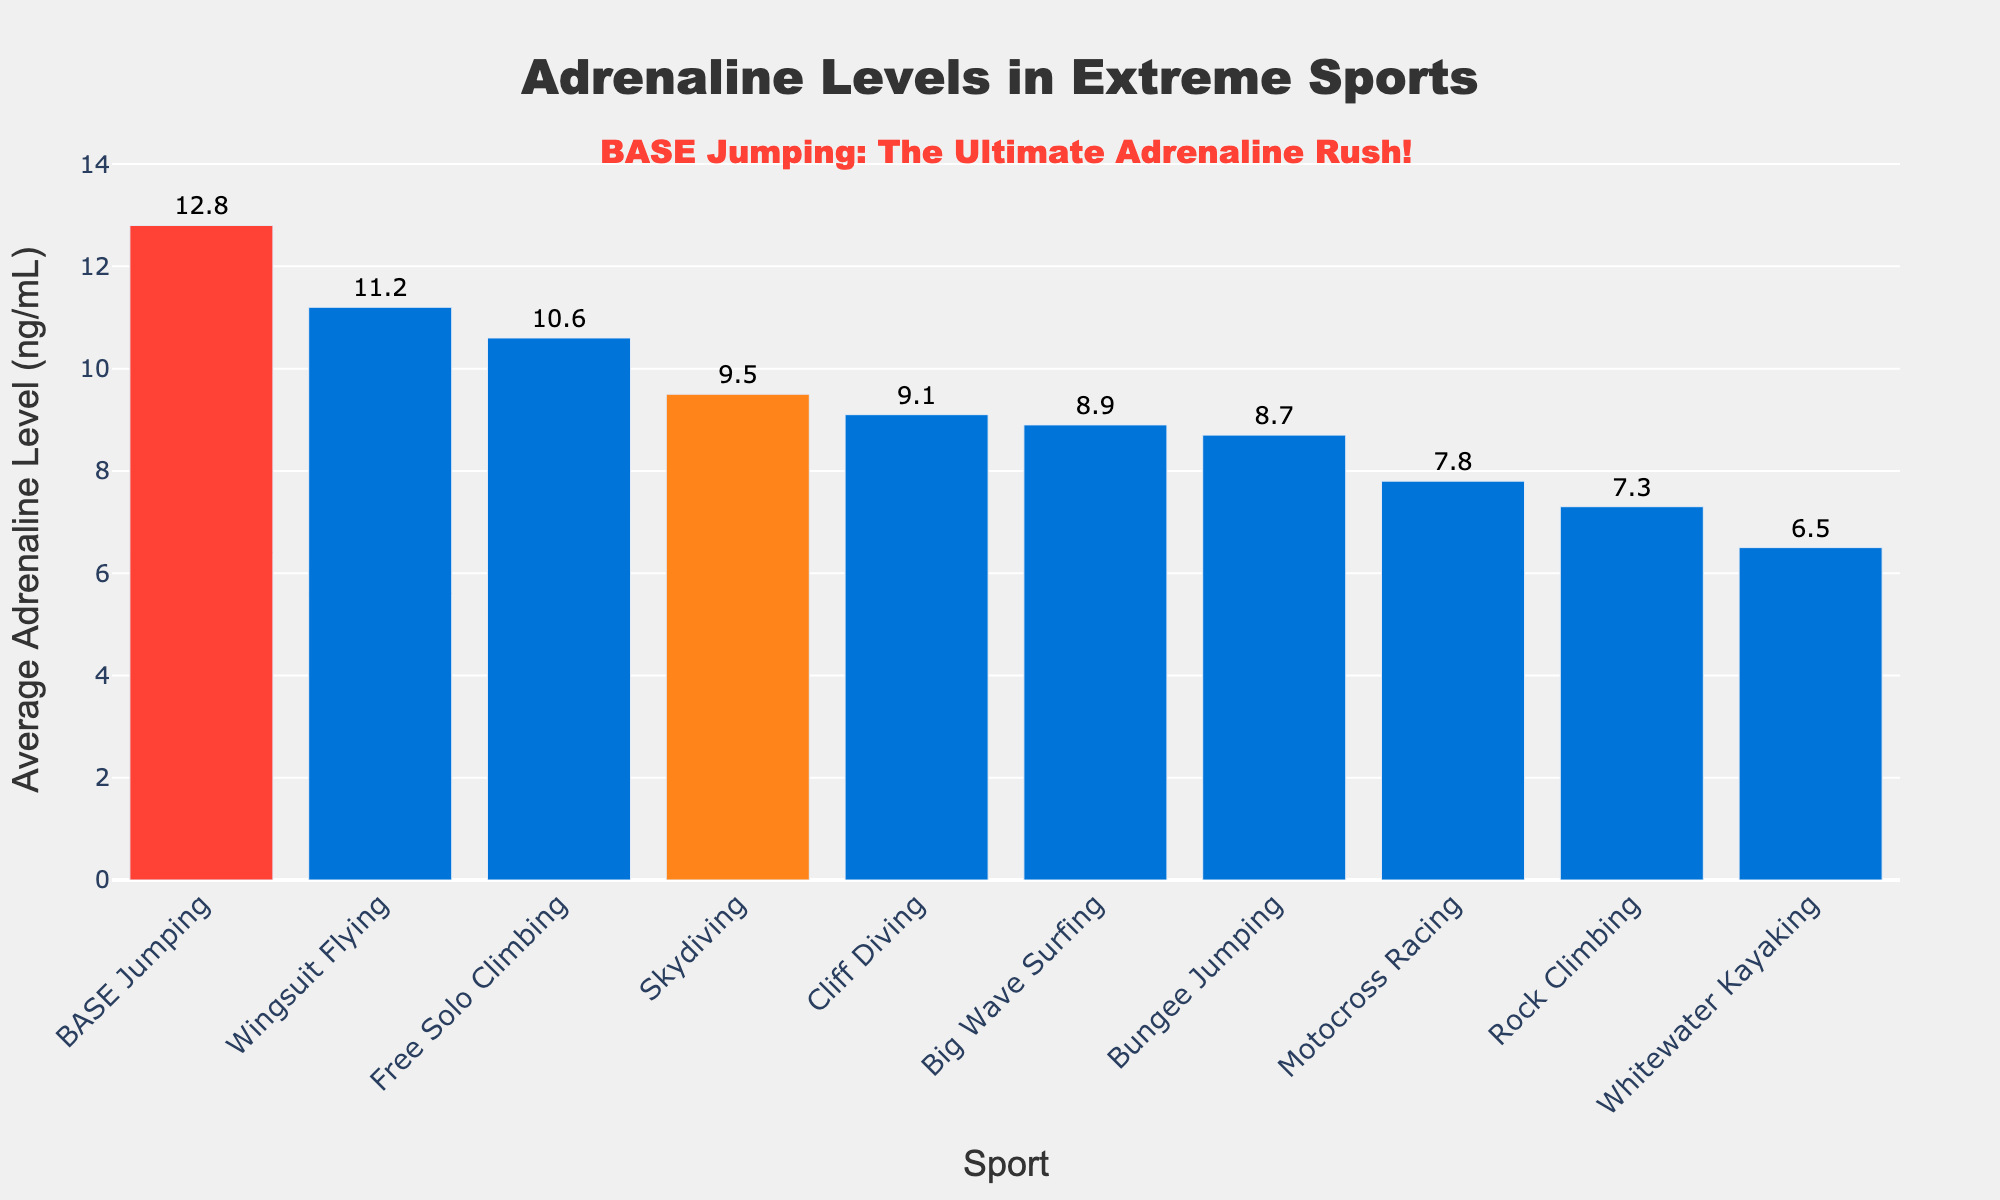What sport has the highest average adrenaline level? By looking at the figure, the highest bar corresponds to BASE Jumping. The text above the bar shows an adrenaline level of 12.8 ng/mL.
Answer: BASE Jumping Which sport has a higher adrenaline level, Bungee Jumping or Big Wave Surfing? By comparing the heights of the bars, Big Wave Surfing has a higher level (8.9 ng/mL) than Bungee Jumping (8.7 ng/mL).
Answer: Big Wave Surfing How much higher is the adrenaline level for BASE Jumping compared to Skydiving? The adrenaline level for BASE Jumping is 12.8 ng/mL, and for Skydiving, it is 9.5 ng/mL. Subtraction gives 12.8 - 9.5 = 3.3 ng/mL.
Answer: 3.3 ng/mL What is the average adrenaline level of the top three sports? The top three sports by adrenaline levels are BASE Jumping (12.8 ng/mL), Wingsuit Flying (11.2 ng/mL), and Free Solo Climbing (10.6 ng/mL). Summing these gives 12.8 + 11.2 + 10.6 = 34.6 ng/mL. The average is 34.6 / 3 = 11.53 ng/mL.
Answer: 11.53 ng/mL Which two sports have adrenaline levels closest to each other? By comparing the heights of the bars and the numerical labels, Bungee Jumping (8.7 ng/mL) and Cliff Diving (9.1 ng/mL) have the smallest difference (9.1 - 8.7 = 0.4 ng/mL).
Answer: Bungee Jumping and Cliff Diving What is the total adrenaline level for Skydiving, Wingsuit Flying, and Cliff Diving combined? Adding the adrenaline levels: Skydiving (9.5 ng/mL), Wingsuit Flying (11.2 ng/mL), and Cliff Diving (9.1 ng/mL) gives 9.5 + 11.2 + 9.1 = 29.8 ng/mL.
Answer: 29.8 ng/mL Which sports are colored red and orange in the chart, and why? The red bar corresponds to BASE Jumping and the orange bar corresponds to Skydiving. Different colors are used to highlight these two sports specifically.
Answer: BASE Jumping and Skydiving What is the difference in adrenaline levels between the highest and lowest sport? BASE Jumping has the highest level (12.8 ng/mL), and Whitewater Kayaking has the lowest (6.5 ng/mL). The difference is 12.8 - 6.5 = 6.3 ng/mL.
Answer: 6.3 ng/mL Ignoring BASE Jumping, which sport has the next highest adrenaline level? The next highest adrenaline level after BASE Jumping (12.8 ng/mL) is found with Wingsuit Flying at 11.2 ng/mL.
Answer: Wingsuit Flying 